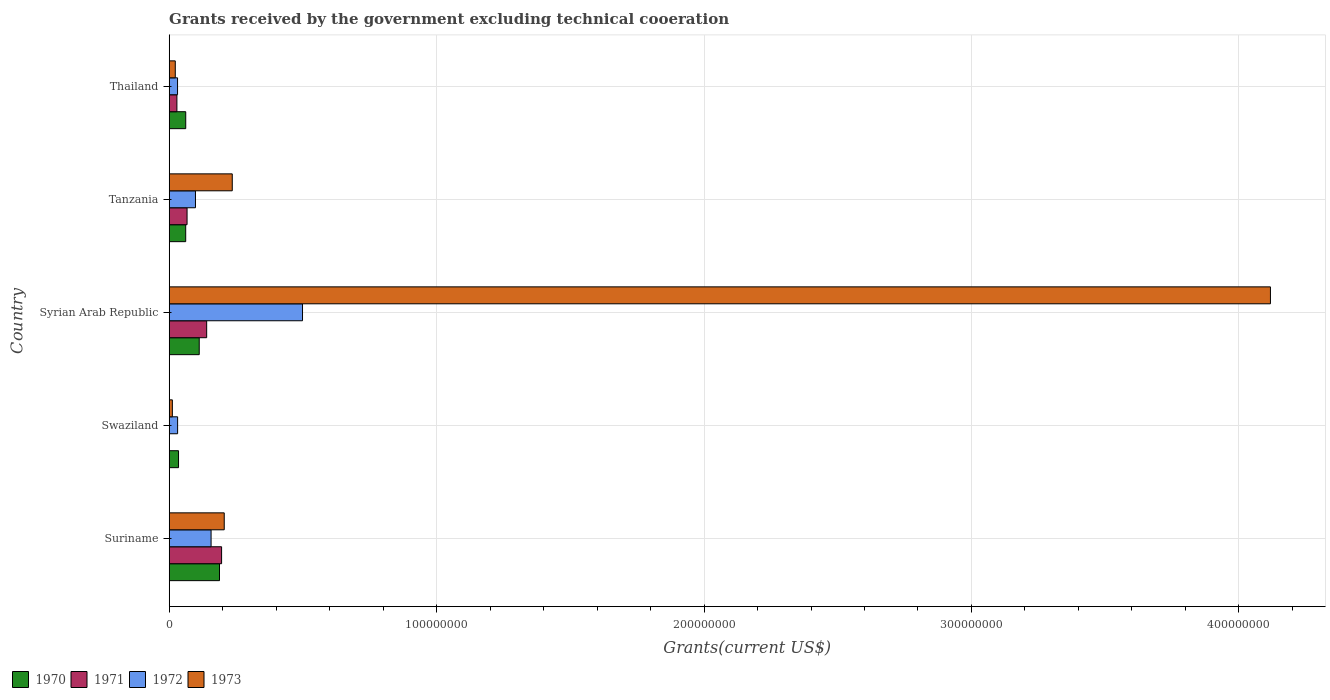How many different coloured bars are there?
Your response must be concise. 4. Are the number of bars on each tick of the Y-axis equal?
Give a very brief answer. No. How many bars are there on the 3rd tick from the top?
Provide a succinct answer. 4. How many bars are there on the 1st tick from the bottom?
Make the answer very short. 4. What is the label of the 1st group of bars from the top?
Provide a succinct answer. Thailand. In how many cases, is the number of bars for a given country not equal to the number of legend labels?
Make the answer very short. 1. What is the total grants received by the government in 1972 in Syrian Arab Republic?
Offer a very short reply. 4.98e+07. Across all countries, what is the maximum total grants received by the government in 1970?
Keep it short and to the point. 1.88e+07. Across all countries, what is the minimum total grants received by the government in 1970?
Your answer should be compact. 3.49e+06. In which country was the total grants received by the government in 1973 maximum?
Provide a short and direct response. Syrian Arab Republic. What is the total total grants received by the government in 1970 in the graph?
Offer a terse response. 4.59e+07. What is the difference between the total grants received by the government in 1972 in Suriname and that in Swaziland?
Ensure brevity in your answer.  1.25e+07. What is the difference between the total grants received by the government in 1970 in Swaziland and the total grants received by the government in 1972 in Thailand?
Provide a short and direct response. 3.70e+05. What is the average total grants received by the government in 1970 per country?
Keep it short and to the point. 9.18e+06. What is the difference between the total grants received by the government in 1972 and total grants received by the government in 1970 in Suriname?
Ensure brevity in your answer.  -3.15e+06. In how many countries, is the total grants received by the government in 1973 greater than 220000000 US$?
Offer a terse response. 1. What is the ratio of the total grants received by the government in 1970 in Swaziland to that in Thailand?
Your answer should be compact. 0.56. Is the total grants received by the government in 1970 in Suriname less than that in Tanzania?
Offer a terse response. No. Is the difference between the total grants received by the government in 1972 in Suriname and Tanzania greater than the difference between the total grants received by the government in 1970 in Suriname and Tanzania?
Provide a short and direct response. No. What is the difference between the highest and the second highest total grants received by the government in 1973?
Make the answer very short. 3.88e+08. What is the difference between the highest and the lowest total grants received by the government in 1972?
Your answer should be compact. 4.67e+07. Is the sum of the total grants received by the government in 1973 in Suriname and Thailand greater than the maximum total grants received by the government in 1971 across all countries?
Offer a very short reply. Yes. Where does the legend appear in the graph?
Your response must be concise. Bottom left. How many legend labels are there?
Ensure brevity in your answer.  4. How are the legend labels stacked?
Offer a very short reply. Horizontal. What is the title of the graph?
Ensure brevity in your answer.  Grants received by the government excluding technical cooeration. Does "1991" appear as one of the legend labels in the graph?
Your response must be concise. No. What is the label or title of the X-axis?
Make the answer very short. Grants(current US$). What is the Grants(current US$) in 1970 in Suriname?
Keep it short and to the point. 1.88e+07. What is the Grants(current US$) in 1971 in Suriname?
Your answer should be very brief. 1.96e+07. What is the Grants(current US$) of 1972 in Suriname?
Your response must be concise. 1.57e+07. What is the Grants(current US$) in 1973 in Suriname?
Your response must be concise. 2.06e+07. What is the Grants(current US$) in 1970 in Swaziland?
Offer a terse response. 3.49e+06. What is the Grants(current US$) of 1971 in Swaziland?
Provide a succinct answer. 0. What is the Grants(current US$) in 1972 in Swaziland?
Offer a very short reply. 3.14e+06. What is the Grants(current US$) in 1973 in Swaziland?
Keep it short and to the point. 1.18e+06. What is the Grants(current US$) of 1970 in Syrian Arab Republic?
Make the answer very short. 1.12e+07. What is the Grants(current US$) of 1971 in Syrian Arab Republic?
Your response must be concise. 1.40e+07. What is the Grants(current US$) of 1972 in Syrian Arab Republic?
Your answer should be very brief. 4.98e+07. What is the Grants(current US$) in 1973 in Syrian Arab Republic?
Your answer should be compact. 4.12e+08. What is the Grants(current US$) of 1970 in Tanzania?
Give a very brief answer. 6.17e+06. What is the Grants(current US$) in 1971 in Tanzania?
Your answer should be compact. 6.68e+06. What is the Grants(current US$) in 1972 in Tanzania?
Ensure brevity in your answer.  9.82e+06. What is the Grants(current US$) of 1973 in Tanzania?
Provide a succinct answer. 2.36e+07. What is the Grants(current US$) in 1970 in Thailand?
Keep it short and to the point. 6.18e+06. What is the Grants(current US$) of 1971 in Thailand?
Provide a succinct answer. 2.88e+06. What is the Grants(current US$) of 1972 in Thailand?
Give a very brief answer. 3.12e+06. What is the Grants(current US$) of 1973 in Thailand?
Your answer should be very brief. 2.27e+06. Across all countries, what is the maximum Grants(current US$) of 1970?
Keep it short and to the point. 1.88e+07. Across all countries, what is the maximum Grants(current US$) in 1971?
Make the answer very short. 1.96e+07. Across all countries, what is the maximum Grants(current US$) of 1972?
Ensure brevity in your answer.  4.98e+07. Across all countries, what is the maximum Grants(current US$) of 1973?
Your answer should be very brief. 4.12e+08. Across all countries, what is the minimum Grants(current US$) in 1970?
Give a very brief answer. 3.49e+06. Across all countries, what is the minimum Grants(current US$) in 1971?
Provide a succinct answer. 0. Across all countries, what is the minimum Grants(current US$) of 1972?
Keep it short and to the point. 3.12e+06. Across all countries, what is the minimum Grants(current US$) in 1973?
Ensure brevity in your answer.  1.18e+06. What is the total Grants(current US$) in 1970 in the graph?
Provide a short and direct response. 4.59e+07. What is the total Grants(current US$) in 1971 in the graph?
Your answer should be very brief. 4.32e+07. What is the total Grants(current US$) of 1972 in the graph?
Provide a succinct answer. 8.16e+07. What is the total Grants(current US$) of 1973 in the graph?
Your answer should be compact. 4.59e+08. What is the difference between the Grants(current US$) of 1970 in Suriname and that in Swaziland?
Ensure brevity in your answer.  1.53e+07. What is the difference between the Grants(current US$) in 1972 in Suriname and that in Swaziland?
Offer a very short reply. 1.25e+07. What is the difference between the Grants(current US$) of 1973 in Suriname and that in Swaziland?
Your response must be concise. 1.94e+07. What is the difference between the Grants(current US$) of 1970 in Suriname and that in Syrian Arab Republic?
Your answer should be very brief. 7.58e+06. What is the difference between the Grants(current US$) of 1971 in Suriname and that in Syrian Arab Republic?
Your answer should be compact. 5.58e+06. What is the difference between the Grants(current US$) of 1972 in Suriname and that in Syrian Arab Republic?
Make the answer very short. -3.42e+07. What is the difference between the Grants(current US$) of 1973 in Suriname and that in Syrian Arab Republic?
Offer a very short reply. -3.91e+08. What is the difference between the Grants(current US$) in 1970 in Suriname and that in Tanzania?
Offer a very short reply. 1.26e+07. What is the difference between the Grants(current US$) of 1971 in Suriname and that in Tanzania?
Give a very brief answer. 1.29e+07. What is the difference between the Grants(current US$) in 1972 in Suriname and that in Tanzania?
Your answer should be very brief. 5.84e+06. What is the difference between the Grants(current US$) of 1973 in Suriname and that in Tanzania?
Keep it short and to the point. -3.00e+06. What is the difference between the Grants(current US$) of 1970 in Suriname and that in Thailand?
Your answer should be very brief. 1.26e+07. What is the difference between the Grants(current US$) of 1971 in Suriname and that in Thailand?
Your answer should be compact. 1.67e+07. What is the difference between the Grants(current US$) of 1972 in Suriname and that in Thailand?
Make the answer very short. 1.25e+07. What is the difference between the Grants(current US$) in 1973 in Suriname and that in Thailand?
Offer a very short reply. 1.83e+07. What is the difference between the Grants(current US$) of 1970 in Swaziland and that in Syrian Arab Republic?
Your answer should be very brief. -7.74e+06. What is the difference between the Grants(current US$) in 1972 in Swaziland and that in Syrian Arab Republic?
Keep it short and to the point. -4.67e+07. What is the difference between the Grants(current US$) in 1973 in Swaziland and that in Syrian Arab Republic?
Give a very brief answer. -4.11e+08. What is the difference between the Grants(current US$) of 1970 in Swaziland and that in Tanzania?
Offer a terse response. -2.68e+06. What is the difference between the Grants(current US$) in 1972 in Swaziland and that in Tanzania?
Your answer should be very brief. -6.68e+06. What is the difference between the Grants(current US$) of 1973 in Swaziland and that in Tanzania?
Make the answer very short. -2.24e+07. What is the difference between the Grants(current US$) in 1970 in Swaziland and that in Thailand?
Your response must be concise. -2.69e+06. What is the difference between the Grants(current US$) in 1973 in Swaziland and that in Thailand?
Provide a short and direct response. -1.09e+06. What is the difference between the Grants(current US$) of 1970 in Syrian Arab Republic and that in Tanzania?
Provide a short and direct response. 5.06e+06. What is the difference between the Grants(current US$) in 1971 in Syrian Arab Republic and that in Tanzania?
Ensure brevity in your answer.  7.33e+06. What is the difference between the Grants(current US$) of 1972 in Syrian Arab Republic and that in Tanzania?
Offer a terse response. 4.00e+07. What is the difference between the Grants(current US$) in 1973 in Syrian Arab Republic and that in Tanzania?
Ensure brevity in your answer.  3.88e+08. What is the difference between the Grants(current US$) of 1970 in Syrian Arab Republic and that in Thailand?
Give a very brief answer. 5.05e+06. What is the difference between the Grants(current US$) in 1971 in Syrian Arab Republic and that in Thailand?
Your answer should be compact. 1.11e+07. What is the difference between the Grants(current US$) in 1972 in Syrian Arab Republic and that in Thailand?
Ensure brevity in your answer.  4.67e+07. What is the difference between the Grants(current US$) in 1973 in Syrian Arab Republic and that in Thailand?
Provide a succinct answer. 4.10e+08. What is the difference between the Grants(current US$) in 1971 in Tanzania and that in Thailand?
Your answer should be very brief. 3.80e+06. What is the difference between the Grants(current US$) in 1972 in Tanzania and that in Thailand?
Your response must be concise. 6.70e+06. What is the difference between the Grants(current US$) of 1973 in Tanzania and that in Thailand?
Your response must be concise. 2.13e+07. What is the difference between the Grants(current US$) of 1970 in Suriname and the Grants(current US$) of 1972 in Swaziland?
Offer a terse response. 1.57e+07. What is the difference between the Grants(current US$) in 1970 in Suriname and the Grants(current US$) in 1973 in Swaziland?
Your response must be concise. 1.76e+07. What is the difference between the Grants(current US$) in 1971 in Suriname and the Grants(current US$) in 1972 in Swaziland?
Your answer should be compact. 1.64e+07. What is the difference between the Grants(current US$) of 1971 in Suriname and the Grants(current US$) of 1973 in Swaziland?
Keep it short and to the point. 1.84e+07. What is the difference between the Grants(current US$) in 1972 in Suriname and the Grants(current US$) in 1973 in Swaziland?
Offer a very short reply. 1.45e+07. What is the difference between the Grants(current US$) of 1970 in Suriname and the Grants(current US$) of 1971 in Syrian Arab Republic?
Your response must be concise. 4.80e+06. What is the difference between the Grants(current US$) of 1970 in Suriname and the Grants(current US$) of 1972 in Syrian Arab Republic?
Make the answer very short. -3.10e+07. What is the difference between the Grants(current US$) in 1970 in Suriname and the Grants(current US$) in 1973 in Syrian Arab Republic?
Give a very brief answer. -3.93e+08. What is the difference between the Grants(current US$) of 1971 in Suriname and the Grants(current US$) of 1972 in Syrian Arab Republic?
Your response must be concise. -3.03e+07. What is the difference between the Grants(current US$) in 1971 in Suriname and the Grants(current US$) in 1973 in Syrian Arab Republic?
Make the answer very short. -3.92e+08. What is the difference between the Grants(current US$) of 1972 in Suriname and the Grants(current US$) of 1973 in Syrian Arab Republic?
Your response must be concise. -3.96e+08. What is the difference between the Grants(current US$) of 1970 in Suriname and the Grants(current US$) of 1971 in Tanzania?
Offer a very short reply. 1.21e+07. What is the difference between the Grants(current US$) in 1970 in Suriname and the Grants(current US$) in 1972 in Tanzania?
Give a very brief answer. 8.99e+06. What is the difference between the Grants(current US$) of 1970 in Suriname and the Grants(current US$) of 1973 in Tanzania?
Offer a terse response. -4.77e+06. What is the difference between the Grants(current US$) in 1971 in Suriname and the Grants(current US$) in 1972 in Tanzania?
Provide a succinct answer. 9.77e+06. What is the difference between the Grants(current US$) in 1971 in Suriname and the Grants(current US$) in 1973 in Tanzania?
Offer a very short reply. -3.99e+06. What is the difference between the Grants(current US$) of 1972 in Suriname and the Grants(current US$) of 1973 in Tanzania?
Make the answer very short. -7.92e+06. What is the difference between the Grants(current US$) in 1970 in Suriname and the Grants(current US$) in 1971 in Thailand?
Your answer should be compact. 1.59e+07. What is the difference between the Grants(current US$) of 1970 in Suriname and the Grants(current US$) of 1972 in Thailand?
Keep it short and to the point. 1.57e+07. What is the difference between the Grants(current US$) of 1970 in Suriname and the Grants(current US$) of 1973 in Thailand?
Provide a succinct answer. 1.65e+07. What is the difference between the Grants(current US$) of 1971 in Suriname and the Grants(current US$) of 1972 in Thailand?
Keep it short and to the point. 1.65e+07. What is the difference between the Grants(current US$) in 1971 in Suriname and the Grants(current US$) in 1973 in Thailand?
Give a very brief answer. 1.73e+07. What is the difference between the Grants(current US$) of 1972 in Suriname and the Grants(current US$) of 1973 in Thailand?
Your answer should be compact. 1.34e+07. What is the difference between the Grants(current US$) in 1970 in Swaziland and the Grants(current US$) in 1971 in Syrian Arab Republic?
Offer a terse response. -1.05e+07. What is the difference between the Grants(current US$) of 1970 in Swaziland and the Grants(current US$) of 1972 in Syrian Arab Republic?
Offer a terse response. -4.64e+07. What is the difference between the Grants(current US$) in 1970 in Swaziland and the Grants(current US$) in 1973 in Syrian Arab Republic?
Your answer should be very brief. -4.08e+08. What is the difference between the Grants(current US$) in 1972 in Swaziland and the Grants(current US$) in 1973 in Syrian Arab Republic?
Give a very brief answer. -4.09e+08. What is the difference between the Grants(current US$) of 1970 in Swaziland and the Grants(current US$) of 1971 in Tanzania?
Your response must be concise. -3.19e+06. What is the difference between the Grants(current US$) of 1970 in Swaziland and the Grants(current US$) of 1972 in Tanzania?
Make the answer very short. -6.33e+06. What is the difference between the Grants(current US$) of 1970 in Swaziland and the Grants(current US$) of 1973 in Tanzania?
Keep it short and to the point. -2.01e+07. What is the difference between the Grants(current US$) in 1972 in Swaziland and the Grants(current US$) in 1973 in Tanzania?
Offer a terse response. -2.04e+07. What is the difference between the Grants(current US$) of 1970 in Swaziland and the Grants(current US$) of 1973 in Thailand?
Your response must be concise. 1.22e+06. What is the difference between the Grants(current US$) of 1972 in Swaziland and the Grants(current US$) of 1973 in Thailand?
Your answer should be very brief. 8.70e+05. What is the difference between the Grants(current US$) of 1970 in Syrian Arab Republic and the Grants(current US$) of 1971 in Tanzania?
Your response must be concise. 4.55e+06. What is the difference between the Grants(current US$) of 1970 in Syrian Arab Republic and the Grants(current US$) of 1972 in Tanzania?
Your response must be concise. 1.41e+06. What is the difference between the Grants(current US$) in 1970 in Syrian Arab Republic and the Grants(current US$) in 1973 in Tanzania?
Offer a terse response. -1.24e+07. What is the difference between the Grants(current US$) of 1971 in Syrian Arab Republic and the Grants(current US$) of 1972 in Tanzania?
Keep it short and to the point. 4.19e+06. What is the difference between the Grants(current US$) of 1971 in Syrian Arab Republic and the Grants(current US$) of 1973 in Tanzania?
Offer a terse response. -9.57e+06. What is the difference between the Grants(current US$) of 1972 in Syrian Arab Republic and the Grants(current US$) of 1973 in Tanzania?
Your answer should be very brief. 2.63e+07. What is the difference between the Grants(current US$) in 1970 in Syrian Arab Republic and the Grants(current US$) in 1971 in Thailand?
Provide a succinct answer. 8.35e+06. What is the difference between the Grants(current US$) of 1970 in Syrian Arab Republic and the Grants(current US$) of 1972 in Thailand?
Keep it short and to the point. 8.11e+06. What is the difference between the Grants(current US$) of 1970 in Syrian Arab Republic and the Grants(current US$) of 1973 in Thailand?
Ensure brevity in your answer.  8.96e+06. What is the difference between the Grants(current US$) of 1971 in Syrian Arab Republic and the Grants(current US$) of 1972 in Thailand?
Your answer should be compact. 1.09e+07. What is the difference between the Grants(current US$) in 1971 in Syrian Arab Republic and the Grants(current US$) in 1973 in Thailand?
Your response must be concise. 1.17e+07. What is the difference between the Grants(current US$) of 1972 in Syrian Arab Republic and the Grants(current US$) of 1973 in Thailand?
Ensure brevity in your answer.  4.76e+07. What is the difference between the Grants(current US$) in 1970 in Tanzania and the Grants(current US$) in 1971 in Thailand?
Give a very brief answer. 3.29e+06. What is the difference between the Grants(current US$) of 1970 in Tanzania and the Grants(current US$) of 1972 in Thailand?
Keep it short and to the point. 3.05e+06. What is the difference between the Grants(current US$) of 1970 in Tanzania and the Grants(current US$) of 1973 in Thailand?
Your response must be concise. 3.90e+06. What is the difference between the Grants(current US$) of 1971 in Tanzania and the Grants(current US$) of 1972 in Thailand?
Make the answer very short. 3.56e+06. What is the difference between the Grants(current US$) of 1971 in Tanzania and the Grants(current US$) of 1973 in Thailand?
Keep it short and to the point. 4.41e+06. What is the difference between the Grants(current US$) in 1972 in Tanzania and the Grants(current US$) in 1973 in Thailand?
Your answer should be very brief. 7.55e+06. What is the average Grants(current US$) of 1970 per country?
Make the answer very short. 9.18e+06. What is the average Grants(current US$) of 1971 per country?
Give a very brief answer. 8.63e+06. What is the average Grants(current US$) in 1972 per country?
Offer a terse response. 1.63e+07. What is the average Grants(current US$) of 1973 per country?
Your answer should be compact. 9.19e+07. What is the difference between the Grants(current US$) in 1970 and Grants(current US$) in 1971 in Suriname?
Your answer should be very brief. -7.80e+05. What is the difference between the Grants(current US$) of 1970 and Grants(current US$) of 1972 in Suriname?
Your answer should be very brief. 3.15e+06. What is the difference between the Grants(current US$) of 1970 and Grants(current US$) of 1973 in Suriname?
Your answer should be very brief. -1.77e+06. What is the difference between the Grants(current US$) of 1971 and Grants(current US$) of 1972 in Suriname?
Give a very brief answer. 3.93e+06. What is the difference between the Grants(current US$) in 1971 and Grants(current US$) in 1973 in Suriname?
Provide a succinct answer. -9.90e+05. What is the difference between the Grants(current US$) of 1972 and Grants(current US$) of 1973 in Suriname?
Your response must be concise. -4.92e+06. What is the difference between the Grants(current US$) in 1970 and Grants(current US$) in 1973 in Swaziland?
Your response must be concise. 2.31e+06. What is the difference between the Grants(current US$) of 1972 and Grants(current US$) of 1973 in Swaziland?
Provide a short and direct response. 1.96e+06. What is the difference between the Grants(current US$) of 1970 and Grants(current US$) of 1971 in Syrian Arab Republic?
Your response must be concise. -2.78e+06. What is the difference between the Grants(current US$) of 1970 and Grants(current US$) of 1972 in Syrian Arab Republic?
Your answer should be very brief. -3.86e+07. What is the difference between the Grants(current US$) of 1970 and Grants(current US$) of 1973 in Syrian Arab Republic?
Your response must be concise. -4.01e+08. What is the difference between the Grants(current US$) in 1971 and Grants(current US$) in 1972 in Syrian Arab Republic?
Your answer should be very brief. -3.58e+07. What is the difference between the Grants(current US$) in 1971 and Grants(current US$) in 1973 in Syrian Arab Republic?
Make the answer very short. -3.98e+08. What is the difference between the Grants(current US$) of 1972 and Grants(current US$) of 1973 in Syrian Arab Republic?
Offer a very short reply. -3.62e+08. What is the difference between the Grants(current US$) of 1970 and Grants(current US$) of 1971 in Tanzania?
Make the answer very short. -5.10e+05. What is the difference between the Grants(current US$) of 1970 and Grants(current US$) of 1972 in Tanzania?
Your answer should be compact. -3.65e+06. What is the difference between the Grants(current US$) of 1970 and Grants(current US$) of 1973 in Tanzania?
Your response must be concise. -1.74e+07. What is the difference between the Grants(current US$) of 1971 and Grants(current US$) of 1972 in Tanzania?
Your answer should be compact. -3.14e+06. What is the difference between the Grants(current US$) of 1971 and Grants(current US$) of 1973 in Tanzania?
Your answer should be compact. -1.69e+07. What is the difference between the Grants(current US$) in 1972 and Grants(current US$) in 1973 in Tanzania?
Provide a short and direct response. -1.38e+07. What is the difference between the Grants(current US$) in 1970 and Grants(current US$) in 1971 in Thailand?
Offer a very short reply. 3.30e+06. What is the difference between the Grants(current US$) of 1970 and Grants(current US$) of 1972 in Thailand?
Make the answer very short. 3.06e+06. What is the difference between the Grants(current US$) of 1970 and Grants(current US$) of 1973 in Thailand?
Offer a terse response. 3.91e+06. What is the difference between the Grants(current US$) of 1972 and Grants(current US$) of 1973 in Thailand?
Offer a very short reply. 8.50e+05. What is the ratio of the Grants(current US$) in 1970 in Suriname to that in Swaziland?
Ensure brevity in your answer.  5.39. What is the ratio of the Grants(current US$) in 1972 in Suriname to that in Swaziland?
Make the answer very short. 4.99. What is the ratio of the Grants(current US$) in 1973 in Suriname to that in Swaziland?
Your answer should be compact. 17.44. What is the ratio of the Grants(current US$) in 1970 in Suriname to that in Syrian Arab Republic?
Give a very brief answer. 1.68. What is the ratio of the Grants(current US$) in 1971 in Suriname to that in Syrian Arab Republic?
Offer a terse response. 1.4. What is the ratio of the Grants(current US$) in 1972 in Suriname to that in Syrian Arab Republic?
Your answer should be very brief. 0.31. What is the ratio of the Grants(current US$) in 1970 in Suriname to that in Tanzania?
Your response must be concise. 3.05. What is the ratio of the Grants(current US$) in 1971 in Suriname to that in Tanzania?
Provide a succinct answer. 2.93. What is the ratio of the Grants(current US$) in 1972 in Suriname to that in Tanzania?
Your response must be concise. 1.59. What is the ratio of the Grants(current US$) in 1973 in Suriname to that in Tanzania?
Give a very brief answer. 0.87. What is the ratio of the Grants(current US$) in 1970 in Suriname to that in Thailand?
Give a very brief answer. 3.04. What is the ratio of the Grants(current US$) in 1971 in Suriname to that in Thailand?
Your response must be concise. 6.8. What is the ratio of the Grants(current US$) in 1972 in Suriname to that in Thailand?
Give a very brief answer. 5.02. What is the ratio of the Grants(current US$) of 1973 in Suriname to that in Thailand?
Your answer should be compact. 9.07. What is the ratio of the Grants(current US$) of 1970 in Swaziland to that in Syrian Arab Republic?
Provide a succinct answer. 0.31. What is the ratio of the Grants(current US$) in 1972 in Swaziland to that in Syrian Arab Republic?
Your answer should be compact. 0.06. What is the ratio of the Grants(current US$) in 1973 in Swaziland to that in Syrian Arab Republic?
Your answer should be very brief. 0. What is the ratio of the Grants(current US$) of 1970 in Swaziland to that in Tanzania?
Make the answer very short. 0.57. What is the ratio of the Grants(current US$) of 1972 in Swaziland to that in Tanzania?
Ensure brevity in your answer.  0.32. What is the ratio of the Grants(current US$) of 1970 in Swaziland to that in Thailand?
Your answer should be very brief. 0.56. What is the ratio of the Grants(current US$) in 1972 in Swaziland to that in Thailand?
Ensure brevity in your answer.  1.01. What is the ratio of the Grants(current US$) of 1973 in Swaziland to that in Thailand?
Keep it short and to the point. 0.52. What is the ratio of the Grants(current US$) in 1970 in Syrian Arab Republic to that in Tanzania?
Your response must be concise. 1.82. What is the ratio of the Grants(current US$) in 1971 in Syrian Arab Republic to that in Tanzania?
Provide a short and direct response. 2.1. What is the ratio of the Grants(current US$) in 1972 in Syrian Arab Republic to that in Tanzania?
Give a very brief answer. 5.08. What is the ratio of the Grants(current US$) in 1973 in Syrian Arab Republic to that in Tanzania?
Provide a succinct answer. 17.46. What is the ratio of the Grants(current US$) in 1970 in Syrian Arab Republic to that in Thailand?
Keep it short and to the point. 1.82. What is the ratio of the Grants(current US$) of 1971 in Syrian Arab Republic to that in Thailand?
Your response must be concise. 4.86. What is the ratio of the Grants(current US$) of 1972 in Syrian Arab Republic to that in Thailand?
Your answer should be compact. 15.98. What is the ratio of the Grants(current US$) of 1973 in Syrian Arab Republic to that in Thailand?
Make the answer very short. 181.41. What is the ratio of the Grants(current US$) in 1970 in Tanzania to that in Thailand?
Your response must be concise. 1. What is the ratio of the Grants(current US$) of 1971 in Tanzania to that in Thailand?
Ensure brevity in your answer.  2.32. What is the ratio of the Grants(current US$) of 1972 in Tanzania to that in Thailand?
Your answer should be compact. 3.15. What is the ratio of the Grants(current US$) in 1973 in Tanzania to that in Thailand?
Make the answer very short. 10.39. What is the difference between the highest and the second highest Grants(current US$) of 1970?
Provide a short and direct response. 7.58e+06. What is the difference between the highest and the second highest Grants(current US$) of 1971?
Offer a terse response. 5.58e+06. What is the difference between the highest and the second highest Grants(current US$) in 1972?
Keep it short and to the point. 3.42e+07. What is the difference between the highest and the second highest Grants(current US$) in 1973?
Ensure brevity in your answer.  3.88e+08. What is the difference between the highest and the lowest Grants(current US$) of 1970?
Your response must be concise. 1.53e+07. What is the difference between the highest and the lowest Grants(current US$) of 1971?
Provide a succinct answer. 1.96e+07. What is the difference between the highest and the lowest Grants(current US$) of 1972?
Your answer should be very brief. 4.67e+07. What is the difference between the highest and the lowest Grants(current US$) of 1973?
Ensure brevity in your answer.  4.11e+08. 